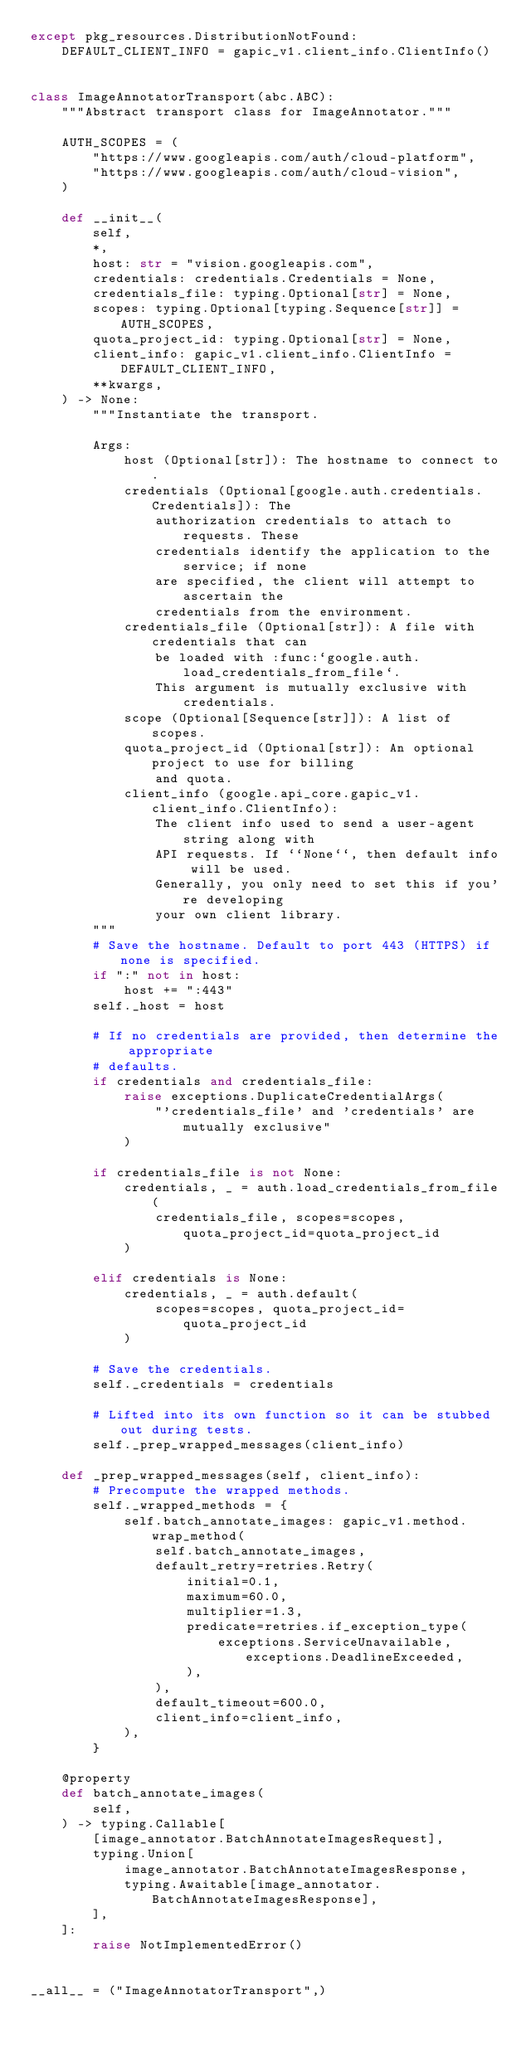Convert code to text. <code><loc_0><loc_0><loc_500><loc_500><_Python_>except pkg_resources.DistributionNotFound:
    DEFAULT_CLIENT_INFO = gapic_v1.client_info.ClientInfo()


class ImageAnnotatorTransport(abc.ABC):
    """Abstract transport class for ImageAnnotator."""

    AUTH_SCOPES = (
        "https://www.googleapis.com/auth/cloud-platform",
        "https://www.googleapis.com/auth/cloud-vision",
    )

    def __init__(
        self,
        *,
        host: str = "vision.googleapis.com",
        credentials: credentials.Credentials = None,
        credentials_file: typing.Optional[str] = None,
        scopes: typing.Optional[typing.Sequence[str]] = AUTH_SCOPES,
        quota_project_id: typing.Optional[str] = None,
        client_info: gapic_v1.client_info.ClientInfo = DEFAULT_CLIENT_INFO,
        **kwargs,
    ) -> None:
        """Instantiate the transport.

        Args:
            host (Optional[str]): The hostname to connect to.
            credentials (Optional[google.auth.credentials.Credentials]): The
                authorization credentials to attach to requests. These
                credentials identify the application to the service; if none
                are specified, the client will attempt to ascertain the
                credentials from the environment.
            credentials_file (Optional[str]): A file with credentials that can
                be loaded with :func:`google.auth.load_credentials_from_file`.
                This argument is mutually exclusive with credentials.
            scope (Optional[Sequence[str]]): A list of scopes.
            quota_project_id (Optional[str]): An optional project to use for billing
                and quota.
            client_info (google.api_core.gapic_v1.client_info.ClientInfo):	
                The client info used to send a user-agent string along with	
                API requests. If ``None``, then default info will be used.	
                Generally, you only need to set this if you're developing	
                your own client library.
        """
        # Save the hostname. Default to port 443 (HTTPS) if none is specified.
        if ":" not in host:
            host += ":443"
        self._host = host

        # If no credentials are provided, then determine the appropriate
        # defaults.
        if credentials and credentials_file:
            raise exceptions.DuplicateCredentialArgs(
                "'credentials_file' and 'credentials' are mutually exclusive"
            )

        if credentials_file is not None:
            credentials, _ = auth.load_credentials_from_file(
                credentials_file, scopes=scopes, quota_project_id=quota_project_id
            )

        elif credentials is None:
            credentials, _ = auth.default(
                scopes=scopes, quota_project_id=quota_project_id
            )

        # Save the credentials.
        self._credentials = credentials

        # Lifted into its own function so it can be stubbed out during tests.
        self._prep_wrapped_messages(client_info)

    def _prep_wrapped_messages(self, client_info):
        # Precompute the wrapped methods.
        self._wrapped_methods = {
            self.batch_annotate_images: gapic_v1.method.wrap_method(
                self.batch_annotate_images,
                default_retry=retries.Retry(
                    initial=0.1,
                    maximum=60.0,
                    multiplier=1.3,
                    predicate=retries.if_exception_type(
                        exceptions.ServiceUnavailable, exceptions.DeadlineExceeded,
                    ),
                ),
                default_timeout=600.0,
                client_info=client_info,
            ),
        }

    @property
    def batch_annotate_images(
        self,
    ) -> typing.Callable[
        [image_annotator.BatchAnnotateImagesRequest],
        typing.Union[
            image_annotator.BatchAnnotateImagesResponse,
            typing.Awaitable[image_annotator.BatchAnnotateImagesResponse],
        ],
    ]:
        raise NotImplementedError()


__all__ = ("ImageAnnotatorTransport",)
</code> 